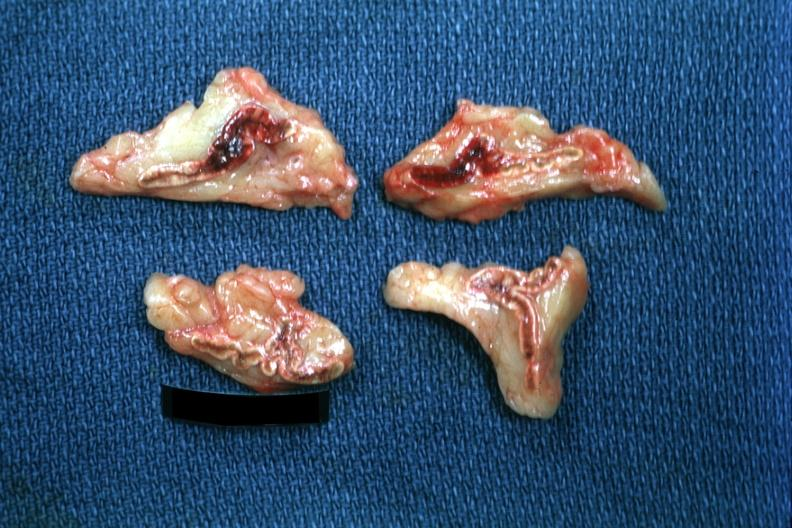s coronary artery anomalous origin left from pulmonary artery present?
Answer the question using a single word or phrase. No 